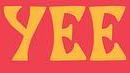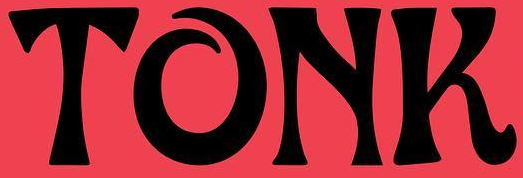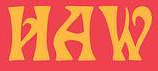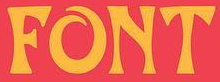Identify the words shown in these images in order, separated by a semicolon. yEE; TONK; HAW; FONT 